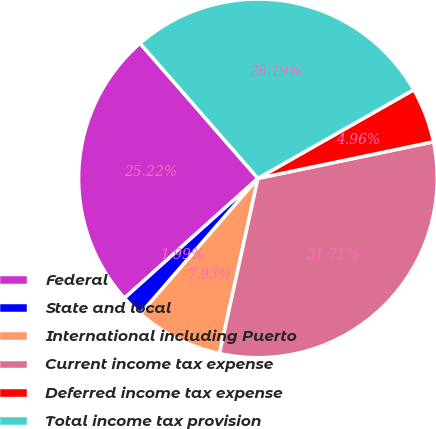<chart> <loc_0><loc_0><loc_500><loc_500><pie_chart><fcel>Federal<fcel>State and local<fcel>International including Puerto<fcel>Current income tax expense<fcel>Deferred income tax expense<fcel>Total income tax provision<nl><fcel>25.22%<fcel>1.99%<fcel>7.93%<fcel>31.71%<fcel>4.96%<fcel>28.19%<nl></chart> 